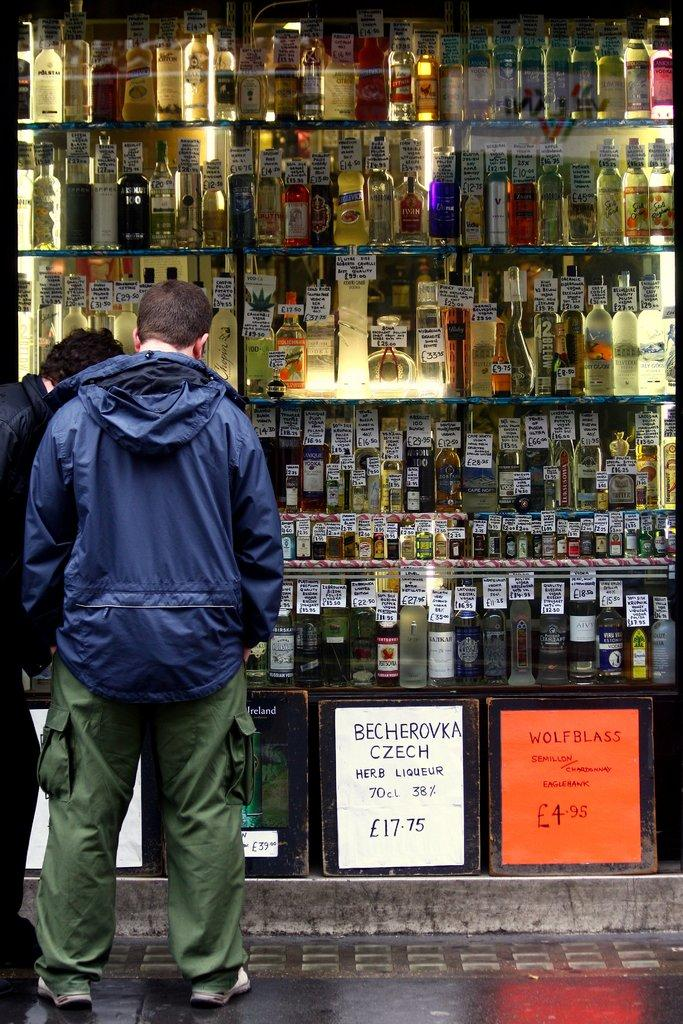<image>
Render a clear and concise summary of the photo. a man standing in front of a lot of liquor bottles and a sign advertising becherovka czech 